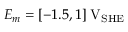Convert formula to latex. <formula><loc_0><loc_0><loc_500><loc_500>E _ { m } = [ - 1 . 5 , 1 ] \, V _ { S H E }</formula> 